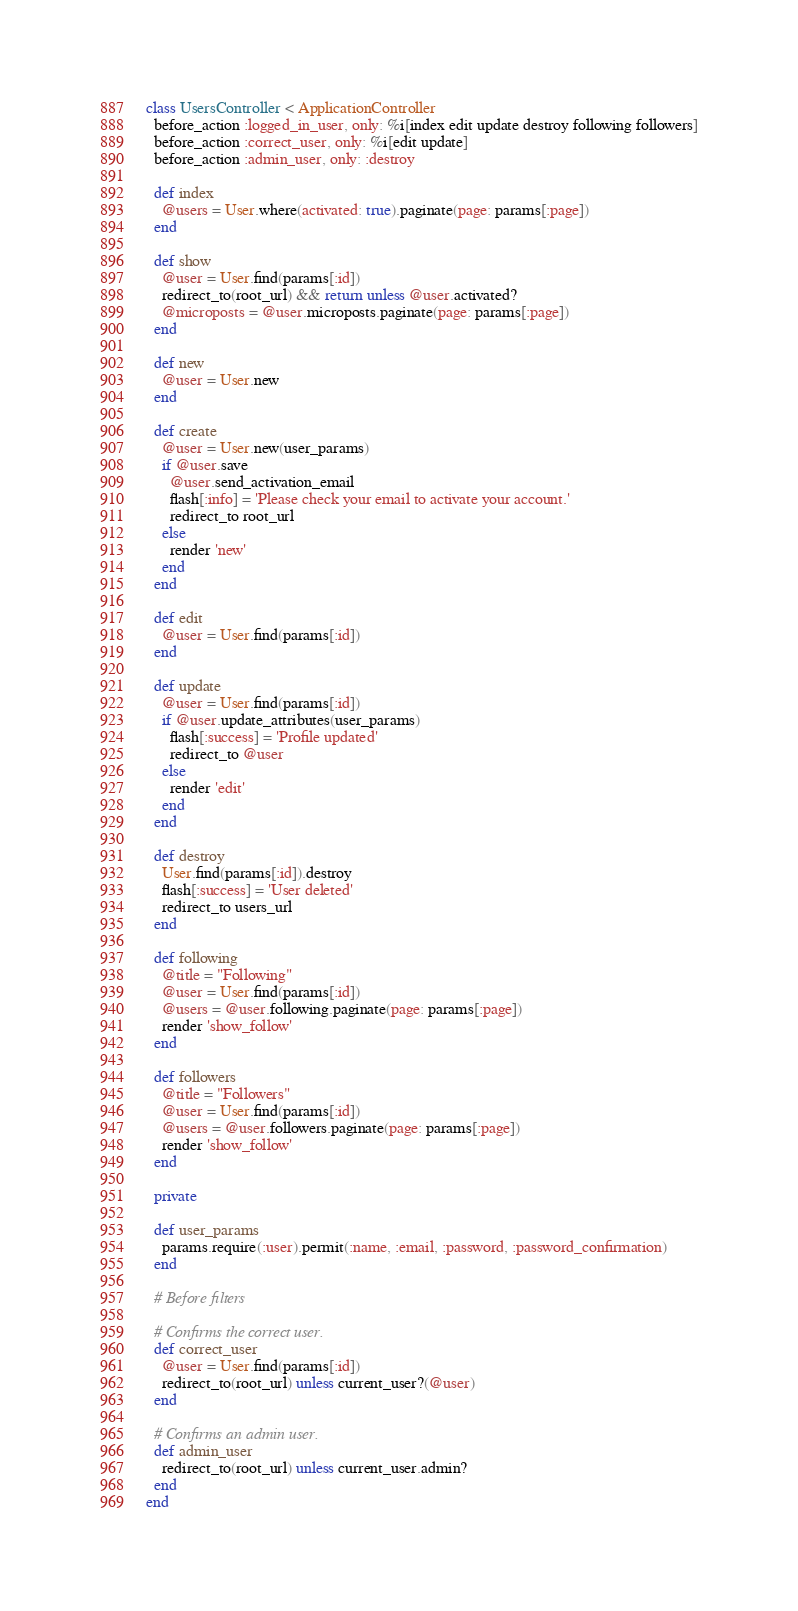Convert code to text. <code><loc_0><loc_0><loc_500><loc_500><_Ruby_>class UsersController < ApplicationController
  before_action :logged_in_user, only: %i[index edit update destroy following followers]
  before_action :correct_user, only: %i[edit update]
  before_action :admin_user, only: :destroy

  def index
    @users = User.where(activated: true).paginate(page: params[:page])
  end

  def show
    @user = User.find(params[:id])
    redirect_to(root_url) && return unless @user.activated?
    @microposts = @user.microposts.paginate(page: params[:page])
  end

  def new
    @user = User.new
  end

  def create
    @user = User.new(user_params)
    if @user.save
      @user.send_activation_email
      flash[:info] = 'Please check your email to activate your account.'
      redirect_to root_url
    else
      render 'new'
    end
  end

  def edit
    @user = User.find(params[:id])
  end

  def update
    @user = User.find(params[:id])
    if @user.update_attributes(user_params)
      flash[:success] = 'Profile updated'
      redirect_to @user
    else
      render 'edit'
    end
  end

  def destroy
    User.find(params[:id]).destroy
    flash[:success] = 'User deleted'
    redirect_to users_url
  end

  def following
    @title = "Following"
    @user = User.find(params[:id])
    @users = @user.following.paginate(page: params[:page])
    render 'show_follow'
  end

  def followers
    @title = "Followers"
    @user = User.find(params[:id])
    @users = @user.followers.paginate(page: params[:page])
    render 'show_follow'
  end

  private

  def user_params
    params.require(:user).permit(:name, :email, :password, :password_confirmation)
  end

  # Before filters

  # Confirms the correct user.
  def correct_user
    @user = User.find(params[:id])
    redirect_to(root_url) unless current_user?(@user)
  end

  # Confirms an admin user.
  def admin_user
    redirect_to(root_url) unless current_user.admin?
  end
end
</code> 